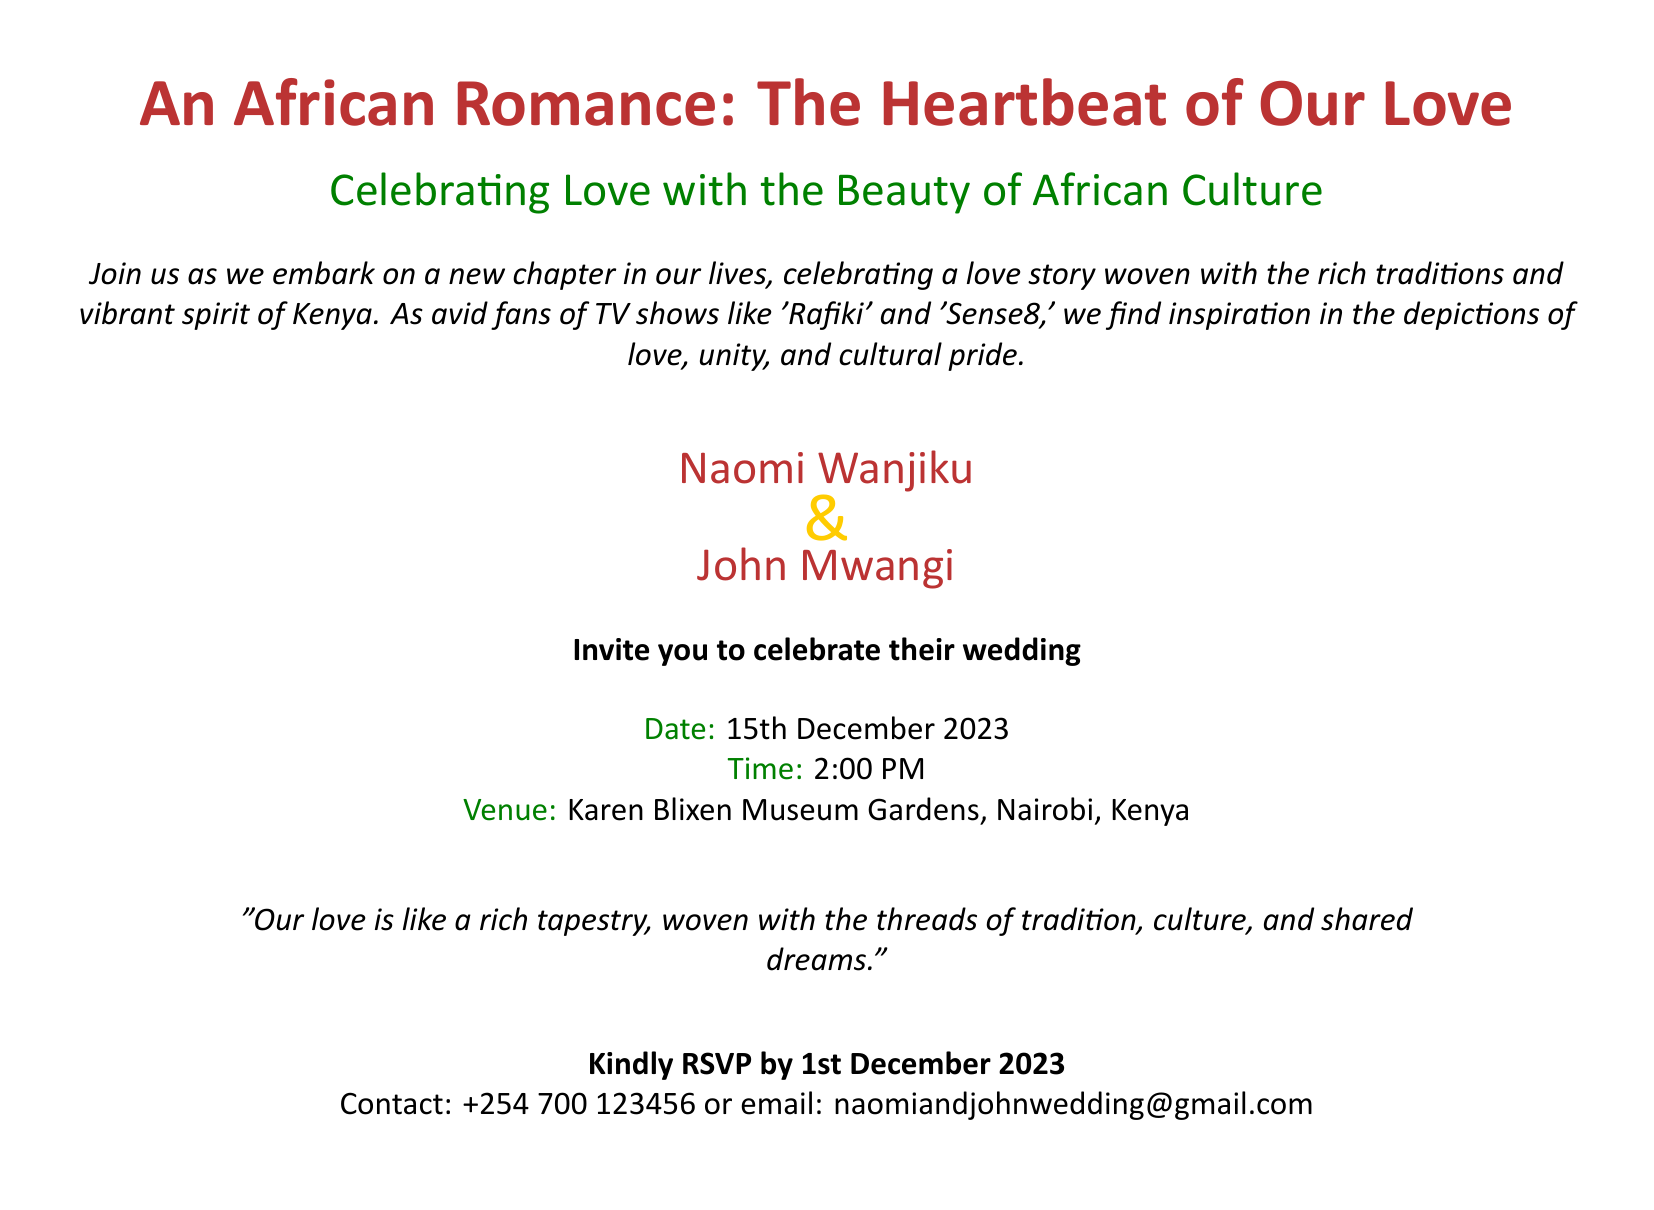What is the title of the invitation? The title of the invitation is prominently displayed at the top of the document.
Answer: An African Romance: The Heartbeat of Our Love Who are the couple getting married? The names of the couple are clearly mentioned in the invitation.
Answer: Naomi Wanjiku & John Mwangi What is the date of the wedding? The wedding date is listed under the event details in the invitation.
Answer: 15th December 2023 What time does the wedding ceremony begin? The time for the wedding ceremony is specified in the invitation.
Answer: 2:00 PM Where is the wedding venue located? The venue is included in the details of the invitation.
Answer: Karen Blixen Museum Gardens, Nairobi, Kenya What is the RSVP deadline? The RSVP deadline is mentioned towards the end of the document.
Answer: 1st December 2023 What contact method is provided for RSVPs? The invitation provides a phone number and an email for RSVPs.
Answer: +254 700 123456 or email: naomiandjohnwedding@gmail.com What cultural elements inspired the couple's love story? The invitation states inspiration drawn from specific TV shows.
Answer: 'Rafiki' and 'Sense8' What is the theme highlighted in the invitation? The theme is indicated in the introductory text of the document.
Answer: The Beauty of African Culture 